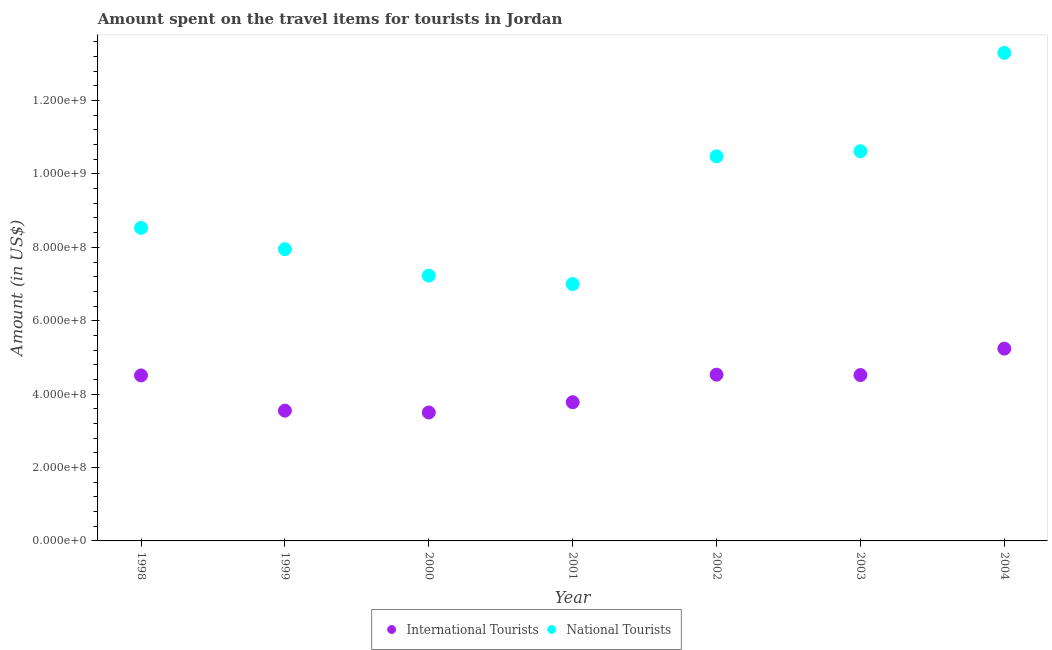How many different coloured dotlines are there?
Provide a succinct answer. 2. Is the number of dotlines equal to the number of legend labels?
Offer a very short reply. Yes. What is the amount spent on travel items of national tourists in 2001?
Keep it short and to the point. 7.00e+08. Across all years, what is the maximum amount spent on travel items of national tourists?
Your answer should be compact. 1.33e+09. Across all years, what is the minimum amount spent on travel items of national tourists?
Provide a short and direct response. 7.00e+08. In which year was the amount spent on travel items of international tourists maximum?
Offer a very short reply. 2004. What is the total amount spent on travel items of national tourists in the graph?
Provide a succinct answer. 6.51e+09. What is the difference between the amount spent on travel items of international tourists in 1999 and that in 2002?
Keep it short and to the point. -9.80e+07. What is the difference between the amount spent on travel items of international tourists in 1999 and the amount spent on travel items of national tourists in 1998?
Your answer should be compact. -4.98e+08. What is the average amount spent on travel items of international tourists per year?
Make the answer very short. 4.23e+08. In the year 2004, what is the difference between the amount spent on travel items of national tourists and amount spent on travel items of international tourists?
Give a very brief answer. 8.06e+08. What is the ratio of the amount spent on travel items of international tourists in 1998 to that in 2000?
Give a very brief answer. 1.29. Is the amount spent on travel items of national tourists in 2001 less than that in 2002?
Offer a terse response. Yes. Is the difference between the amount spent on travel items of international tourists in 2000 and 2002 greater than the difference between the amount spent on travel items of national tourists in 2000 and 2002?
Give a very brief answer. Yes. What is the difference between the highest and the second highest amount spent on travel items of international tourists?
Provide a short and direct response. 7.10e+07. What is the difference between the highest and the lowest amount spent on travel items of international tourists?
Your response must be concise. 1.74e+08. In how many years, is the amount spent on travel items of international tourists greater than the average amount spent on travel items of international tourists taken over all years?
Make the answer very short. 4. Is the amount spent on travel items of international tourists strictly less than the amount spent on travel items of national tourists over the years?
Your response must be concise. Yes. How many years are there in the graph?
Offer a terse response. 7. Does the graph contain any zero values?
Provide a succinct answer. No. Does the graph contain grids?
Offer a very short reply. No. Where does the legend appear in the graph?
Make the answer very short. Bottom center. How many legend labels are there?
Give a very brief answer. 2. How are the legend labels stacked?
Keep it short and to the point. Horizontal. What is the title of the graph?
Provide a succinct answer. Amount spent on the travel items for tourists in Jordan. Does "Nitrous oxide" appear as one of the legend labels in the graph?
Offer a terse response. No. What is the label or title of the X-axis?
Offer a terse response. Year. What is the label or title of the Y-axis?
Provide a succinct answer. Amount (in US$). What is the Amount (in US$) in International Tourists in 1998?
Provide a succinct answer. 4.51e+08. What is the Amount (in US$) of National Tourists in 1998?
Offer a very short reply. 8.53e+08. What is the Amount (in US$) of International Tourists in 1999?
Ensure brevity in your answer.  3.55e+08. What is the Amount (in US$) in National Tourists in 1999?
Your response must be concise. 7.95e+08. What is the Amount (in US$) of International Tourists in 2000?
Offer a terse response. 3.50e+08. What is the Amount (in US$) in National Tourists in 2000?
Your response must be concise. 7.23e+08. What is the Amount (in US$) of International Tourists in 2001?
Give a very brief answer. 3.78e+08. What is the Amount (in US$) in National Tourists in 2001?
Your answer should be very brief. 7.00e+08. What is the Amount (in US$) of International Tourists in 2002?
Your answer should be compact. 4.53e+08. What is the Amount (in US$) in National Tourists in 2002?
Give a very brief answer. 1.05e+09. What is the Amount (in US$) in International Tourists in 2003?
Give a very brief answer. 4.52e+08. What is the Amount (in US$) of National Tourists in 2003?
Offer a very short reply. 1.06e+09. What is the Amount (in US$) of International Tourists in 2004?
Keep it short and to the point. 5.24e+08. What is the Amount (in US$) in National Tourists in 2004?
Offer a very short reply. 1.33e+09. Across all years, what is the maximum Amount (in US$) in International Tourists?
Your answer should be compact. 5.24e+08. Across all years, what is the maximum Amount (in US$) of National Tourists?
Provide a succinct answer. 1.33e+09. Across all years, what is the minimum Amount (in US$) in International Tourists?
Your response must be concise. 3.50e+08. Across all years, what is the minimum Amount (in US$) of National Tourists?
Offer a terse response. 7.00e+08. What is the total Amount (in US$) in International Tourists in the graph?
Give a very brief answer. 2.96e+09. What is the total Amount (in US$) in National Tourists in the graph?
Keep it short and to the point. 6.51e+09. What is the difference between the Amount (in US$) in International Tourists in 1998 and that in 1999?
Your answer should be very brief. 9.60e+07. What is the difference between the Amount (in US$) of National Tourists in 1998 and that in 1999?
Your response must be concise. 5.80e+07. What is the difference between the Amount (in US$) of International Tourists in 1998 and that in 2000?
Keep it short and to the point. 1.01e+08. What is the difference between the Amount (in US$) of National Tourists in 1998 and that in 2000?
Keep it short and to the point. 1.30e+08. What is the difference between the Amount (in US$) of International Tourists in 1998 and that in 2001?
Your answer should be compact. 7.30e+07. What is the difference between the Amount (in US$) in National Tourists in 1998 and that in 2001?
Your answer should be compact. 1.53e+08. What is the difference between the Amount (in US$) of International Tourists in 1998 and that in 2002?
Offer a terse response. -2.00e+06. What is the difference between the Amount (in US$) of National Tourists in 1998 and that in 2002?
Offer a terse response. -1.95e+08. What is the difference between the Amount (in US$) of National Tourists in 1998 and that in 2003?
Make the answer very short. -2.09e+08. What is the difference between the Amount (in US$) in International Tourists in 1998 and that in 2004?
Offer a terse response. -7.30e+07. What is the difference between the Amount (in US$) of National Tourists in 1998 and that in 2004?
Make the answer very short. -4.77e+08. What is the difference between the Amount (in US$) of National Tourists in 1999 and that in 2000?
Your answer should be compact. 7.20e+07. What is the difference between the Amount (in US$) of International Tourists in 1999 and that in 2001?
Make the answer very short. -2.30e+07. What is the difference between the Amount (in US$) in National Tourists in 1999 and that in 2001?
Give a very brief answer. 9.50e+07. What is the difference between the Amount (in US$) in International Tourists in 1999 and that in 2002?
Your response must be concise. -9.80e+07. What is the difference between the Amount (in US$) in National Tourists in 1999 and that in 2002?
Keep it short and to the point. -2.53e+08. What is the difference between the Amount (in US$) in International Tourists in 1999 and that in 2003?
Your answer should be very brief. -9.70e+07. What is the difference between the Amount (in US$) in National Tourists in 1999 and that in 2003?
Your response must be concise. -2.67e+08. What is the difference between the Amount (in US$) in International Tourists in 1999 and that in 2004?
Your answer should be very brief. -1.69e+08. What is the difference between the Amount (in US$) of National Tourists in 1999 and that in 2004?
Make the answer very short. -5.35e+08. What is the difference between the Amount (in US$) in International Tourists in 2000 and that in 2001?
Give a very brief answer. -2.80e+07. What is the difference between the Amount (in US$) in National Tourists in 2000 and that in 2001?
Ensure brevity in your answer.  2.30e+07. What is the difference between the Amount (in US$) in International Tourists in 2000 and that in 2002?
Your answer should be compact. -1.03e+08. What is the difference between the Amount (in US$) in National Tourists in 2000 and that in 2002?
Offer a terse response. -3.25e+08. What is the difference between the Amount (in US$) of International Tourists in 2000 and that in 2003?
Ensure brevity in your answer.  -1.02e+08. What is the difference between the Amount (in US$) in National Tourists in 2000 and that in 2003?
Provide a succinct answer. -3.39e+08. What is the difference between the Amount (in US$) of International Tourists in 2000 and that in 2004?
Provide a succinct answer. -1.74e+08. What is the difference between the Amount (in US$) in National Tourists in 2000 and that in 2004?
Give a very brief answer. -6.07e+08. What is the difference between the Amount (in US$) of International Tourists in 2001 and that in 2002?
Provide a short and direct response. -7.50e+07. What is the difference between the Amount (in US$) in National Tourists in 2001 and that in 2002?
Your answer should be very brief. -3.48e+08. What is the difference between the Amount (in US$) of International Tourists in 2001 and that in 2003?
Give a very brief answer. -7.40e+07. What is the difference between the Amount (in US$) in National Tourists in 2001 and that in 2003?
Your answer should be compact. -3.62e+08. What is the difference between the Amount (in US$) of International Tourists in 2001 and that in 2004?
Offer a very short reply. -1.46e+08. What is the difference between the Amount (in US$) in National Tourists in 2001 and that in 2004?
Keep it short and to the point. -6.30e+08. What is the difference between the Amount (in US$) in International Tourists in 2002 and that in 2003?
Provide a succinct answer. 1.00e+06. What is the difference between the Amount (in US$) of National Tourists in 2002 and that in 2003?
Offer a terse response. -1.40e+07. What is the difference between the Amount (in US$) in International Tourists in 2002 and that in 2004?
Offer a very short reply. -7.10e+07. What is the difference between the Amount (in US$) in National Tourists in 2002 and that in 2004?
Offer a very short reply. -2.82e+08. What is the difference between the Amount (in US$) in International Tourists in 2003 and that in 2004?
Offer a very short reply. -7.20e+07. What is the difference between the Amount (in US$) in National Tourists in 2003 and that in 2004?
Your answer should be compact. -2.68e+08. What is the difference between the Amount (in US$) of International Tourists in 1998 and the Amount (in US$) of National Tourists in 1999?
Your response must be concise. -3.44e+08. What is the difference between the Amount (in US$) of International Tourists in 1998 and the Amount (in US$) of National Tourists in 2000?
Offer a terse response. -2.72e+08. What is the difference between the Amount (in US$) in International Tourists in 1998 and the Amount (in US$) in National Tourists in 2001?
Offer a very short reply. -2.49e+08. What is the difference between the Amount (in US$) of International Tourists in 1998 and the Amount (in US$) of National Tourists in 2002?
Your response must be concise. -5.97e+08. What is the difference between the Amount (in US$) in International Tourists in 1998 and the Amount (in US$) in National Tourists in 2003?
Offer a very short reply. -6.11e+08. What is the difference between the Amount (in US$) in International Tourists in 1998 and the Amount (in US$) in National Tourists in 2004?
Ensure brevity in your answer.  -8.79e+08. What is the difference between the Amount (in US$) of International Tourists in 1999 and the Amount (in US$) of National Tourists in 2000?
Ensure brevity in your answer.  -3.68e+08. What is the difference between the Amount (in US$) of International Tourists in 1999 and the Amount (in US$) of National Tourists in 2001?
Make the answer very short. -3.45e+08. What is the difference between the Amount (in US$) of International Tourists in 1999 and the Amount (in US$) of National Tourists in 2002?
Offer a very short reply. -6.93e+08. What is the difference between the Amount (in US$) of International Tourists in 1999 and the Amount (in US$) of National Tourists in 2003?
Your response must be concise. -7.07e+08. What is the difference between the Amount (in US$) in International Tourists in 1999 and the Amount (in US$) in National Tourists in 2004?
Offer a very short reply. -9.75e+08. What is the difference between the Amount (in US$) in International Tourists in 2000 and the Amount (in US$) in National Tourists in 2001?
Offer a terse response. -3.50e+08. What is the difference between the Amount (in US$) of International Tourists in 2000 and the Amount (in US$) of National Tourists in 2002?
Provide a succinct answer. -6.98e+08. What is the difference between the Amount (in US$) in International Tourists in 2000 and the Amount (in US$) in National Tourists in 2003?
Provide a short and direct response. -7.12e+08. What is the difference between the Amount (in US$) in International Tourists in 2000 and the Amount (in US$) in National Tourists in 2004?
Offer a terse response. -9.80e+08. What is the difference between the Amount (in US$) of International Tourists in 2001 and the Amount (in US$) of National Tourists in 2002?
Your answer should be very brief. -6.70e+08. What is the difference between the Amount (in US$) of International Tourists in 2001 and the Amount (in US$) of National Tourists in 2003?
Give a very brief answer. -6.84e+08. What is the difference between the Amount (in US$) of International Tourists in 2001 and the Amount (in US$) of National Tourists in 2004?
Offer a very short reply. -9.52e+08. What is the difference between the Amount (in US$) in International Tourists in 2002 and the Amount (in US$) in National Tourists in 2003?
Your response must be concise. -6.09e+08. What is the difference between the Amount (in US$) of International Tourists in 2002 and the Amount (in US$) of National Tourists in 2004?
Provide a short and direct response. -8.77e+08. What is the difference between the Amount (in US$) in International Tourists in 2003 and the Amount (in US$) in National Tourists in 2004?
Your response must be concise. -8.78e+08. What is the average Amount (in US$) of International Tourists per year?
Offer a very short reply. 4.23e+08. What is the average Amount (in US$) in National Tourists per year?
Offer a terse response. 9.30e+08. In the year 1998, what is the difference between the Amount (in US$) of International Tourists and Amount (in US$) of National Tourists?
Offer a very short reply. -4.02e+08. In the year 1999, what is the difference between the Amount (in US$) of International Tourists and Amount (in US$) of National Tourists?
Keep it short and to the point. -4.40e+08. In the year 2000, what is the difference between the Amount (in US$) in International Tourists and Amount (in US$) in National Tourists?
Offer a very short reply. -3.73e+08. In the year 2001, what is the difference between the Amount (in US$) in International Tourists and Amount (in US$) in National Tourists?
Keep it short and to the point. -3.22e+08. In the year 2002, what is the difference between the Amount (in US$) in International Tourists and Amount (in US$) in National Tourists?
Your answer should be very brief. -5.95e+08. In the year 2003, what is the difference between the Amount (in US$) in International Tourists and Amount (in US$) in National Tourists?
Offer a terse response. -6.10e+08. In the year 2004, what is the difference between the Amount (in US$) in International Tourists and Amount (in US$) in National Tourists?
Ensure brevity in your answer.  -8.06e+08. What is the ratio of the Amount (in US$) in International Tourists in 1998 to that in 1999?
Keep it short and to the point. 1.27. What is the ratio of the Amount (in US$) of National Tourists in 1998 to that in 1999?
Your answer should be compact. 1.07. What is the ratio of the Amount (in US$) in International Tourists in 1998 to that in 2000?
Provide a short and direct response. 1.29. What is the ratio of the Amount (in US$) of National Tourists in 1998 to that in 2000?
Your answer should be compact. 1.18. What is the ratio of the Amount (in US$) in International Tourists in 1998 to that in 2001?
Your response must be concise. 1.19. What is the ratio of the Amount (in US$) of National Tourists in 1998 to that in 2001?
Ensure brevity in your answer.  1.22. What is the ratio of the Amount (in US$) in International Tourists in 1998 to that in 2002?
Give a very brief answer. 1. What is the ratio of the Amount (in US$) of National Tourists in 1998 to that in 2002?
Offer a terse response. 0.81. What is the ratio of the Amount (in US$) in National Tourists in 1998 to that in 2003?
Make the answer very short. 0.8. What is the ratio of the Amount (in US$) of International Tourists in 1998 to that in 2004?
Your answer should be very brief. 0.86. What is the ratio of the Amount (in US$) in National Tourists in 1998 to that in 2004?
Provide a succinct answer. 0.64. What is the ratio of the Amount (in US$) of International Tourists in 1999 to that in 2000?
Ensure brevity in your answer.  1.01. What is the ratio of the Amount (in US$) of National Tourists in 1999 to that in 2000?
Make the answer very short. 1.1. What is the ratio of the Amount (in US$) of International Tourists in 1999 to that in 2001?
Make the answer very short. 0.94. What is the ratio of the Amount (in US$) of National Tourists in 1999 to that in 2001?
Your answer should be very brief. 1.14. What is the ratio of the Amount (in US$) of International Tourists in 1999 to that in 2002?
Give a very brief answer. 0.78. What is the ratio of the Amount (in US$) of National Tourists in 1999 to that in 2002?
Offer a terse response. 0.76. What is the ratio of the Amount (in US$) in International Tourists in 1999 to that in 2003?
Provide a short and direct response. 0.79. What is the ratio of the Amount (in US$) in National Tourists in 1999 to that in 2003?
Provide a short and direct response. 0.75. What is the ratio of the Amount (in US$) of International Tourists in 1999 to that in 2004?
Ensure brevity in your answer.  0.68. What is the ratio of the Amount (in US$) of National Tourists in 1999 to that in 2004?
Your answer should be very brief. 0.6. What is the ratio of the Amount (in US$) in International Tourists in 2000 to that in 2001?
Offer a terse response. 0.93. What is the ratio of the Amount (in US$) of National Tourists in 2000 to that in 2001?
Make the answer very short. 1.03. What is the ratio of the Amount (in US$) in International Tourists in 2000 to that in 2002?
Make the answer very short. 0.77. What is the ratio of the Amount (in US$) of National Tourists in 2000 to that in 2002?
Give a very brief answer. 0.69. What is the ratio of the Amount (in US$) in International Tourists in 2000 to that in 2003?
Make the answer very short. 0.77. What is the ratio of the Amount (in US$) in National Tourists in 2000 to that in 2003?
Offer a terse response. 0.68. What is the ratio of the Amount (in US$) in International Tourists in 2000 to that in 2004?
Your answer should be very brief. 0.67. What is the ratio of the Amount (in US$) in National Tourists in 2000 to that in 2004?
Keep it short and to the point. 0.54. What is the ratio of the Amount (in US$) of International Tourists in 2001 to that in 2002?
Your response must be concise. 0.83. What is the ratio of the Amount (in US$) of National Tourists in 2001 to that in 2002?
Make the answer very short. 0.67. What is the ratio of the Amount (in US$) of International Tourists in 2001 to that in 2003?
Your response must be concise. 0.84. What is the ratio of the Amount (in US$) in National Tourists in 2001 to that in 2003?
Make the answer very short. 0.66. What is the ratio of the Amount (in US$) in International Tourists in 2001 to that in 2004?
Keep it short and to the point. 0.72. What is the ratio of the Amount (in US$) of National Tourists in 2001 to that in 2004?
Give a very brief answer. 0.53. What is the ratio of the Amount (in US$) in International Tourists in 2002 to that in 2003?
Keep it short and to the point. 1. What is the ratio of the Amount (in US$) of National Tourists in 2002 to that in 2003?
Provide a short and direct response. 0.99. What is the ratio of the Amount (in US$) of International Tourists in 2002 to that in 2004?
Ensure brevity in your answer.  0.86. What is the ratio of the Amount (in US$) in National Tourists in 2002 to that in 2004?
Make the answer very short. 0.79. What is the ratio of the Amount (in US$) of International Tourists in 2003 to that in 2004?
Make the answer very short. 0.86. What is the ratio of the Amount (in US$) of National Tourists in 2003 to that in 2004?
Offer a terse response. 0.8. What is the difference between the highest and the second highest Amount (in US$) in International Tourists?
Offer a terse response. 7.10e+07. What is the difference between the highest and the second highest Amount (in US$) of National Tourists?
Your response must be concise. 2.68e+08. What is the difference between the highest and the lowest Amount (in US$) of International Tourists?
Your answer should be very brief. 1.74e+08. What is the difference between the highest and the lowest Amount (in US$) in National Tourists?
Offer a very short reply. 6.30e+08. 